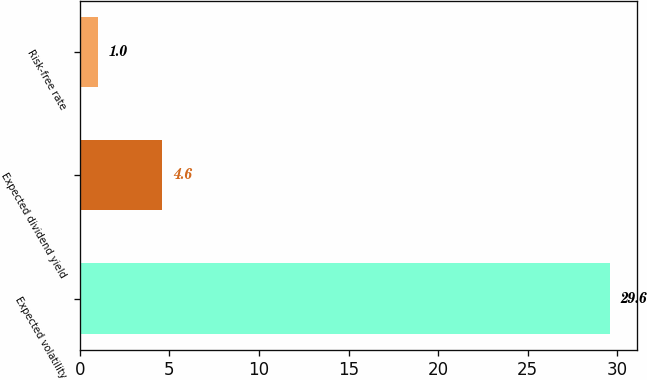Convert chart. <chart><loc_0><loc_0><loc_500><loc_500><bar_chart><fcel>Expected volatility<fcel>Expected dividend yield<fcel>Risk-free rate<nl><fcel>29.6<fcel>4.6<fcel>1<nl></chart> 